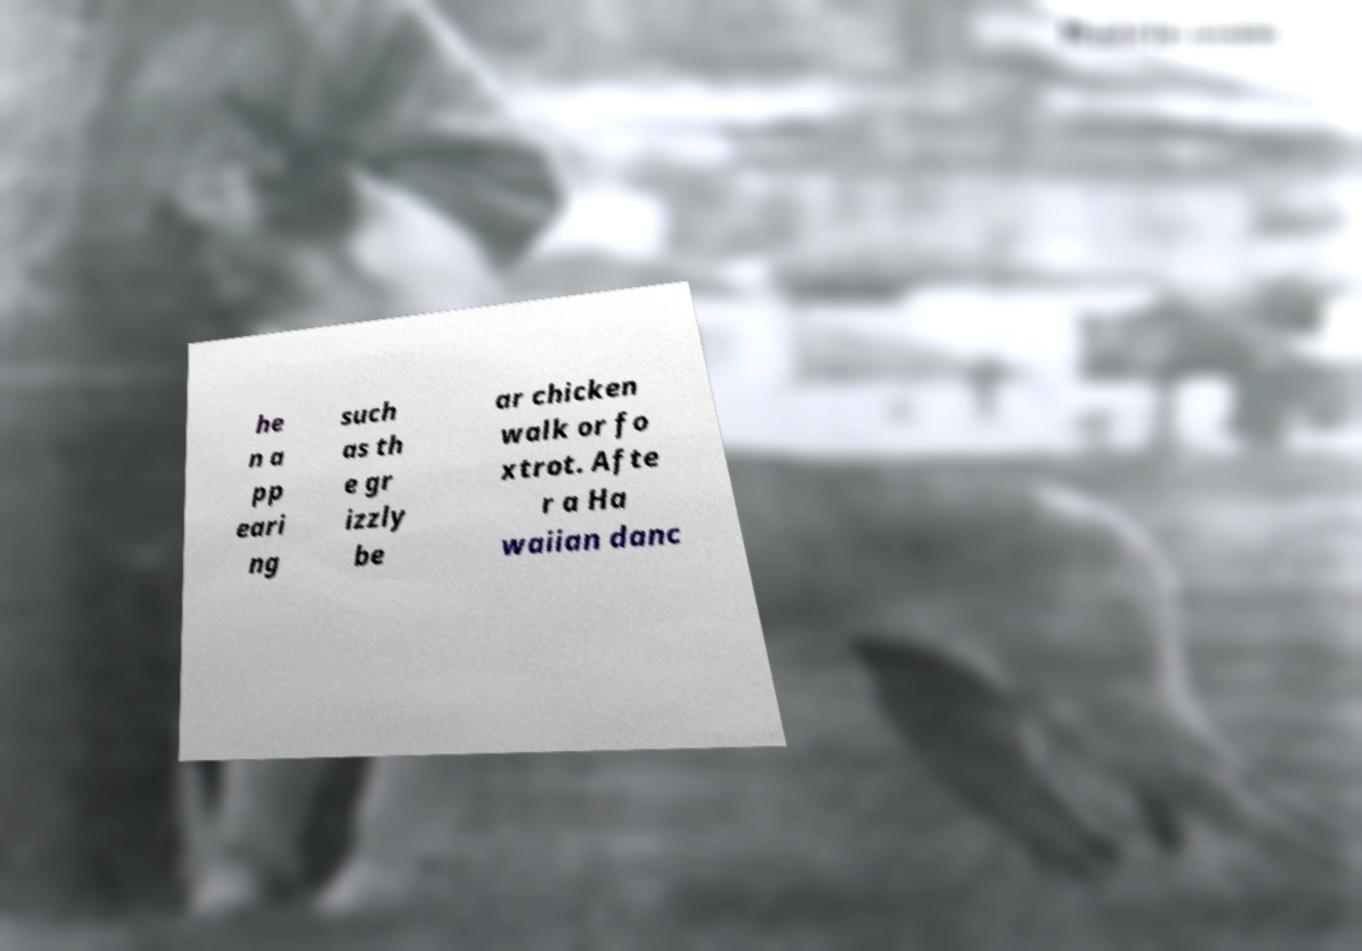Could you extract and type out the text from this image? he n a pp eari ng such as th e gr izzly be ar chicken walk or fo xtrot. Afte r a Ha waiian danc 